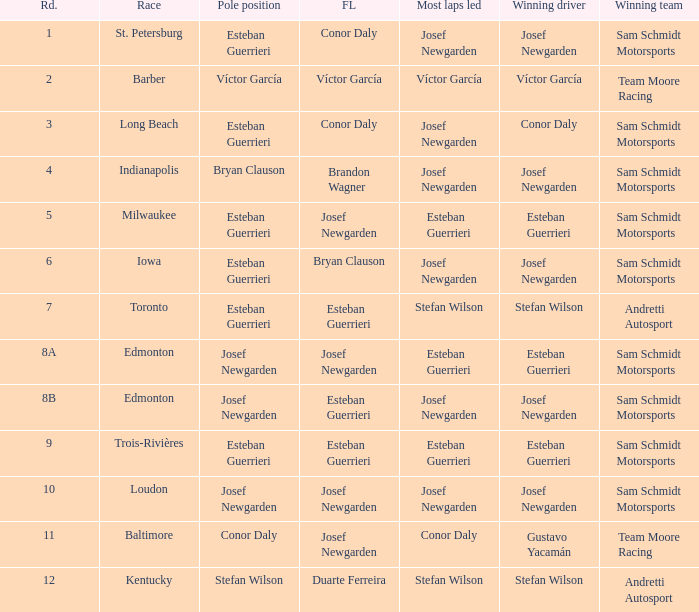Who had the pole(s) when esteban guerrieri led the most laps round 8a and josef newgarden had the fastest lap? Josef Newgarden. 